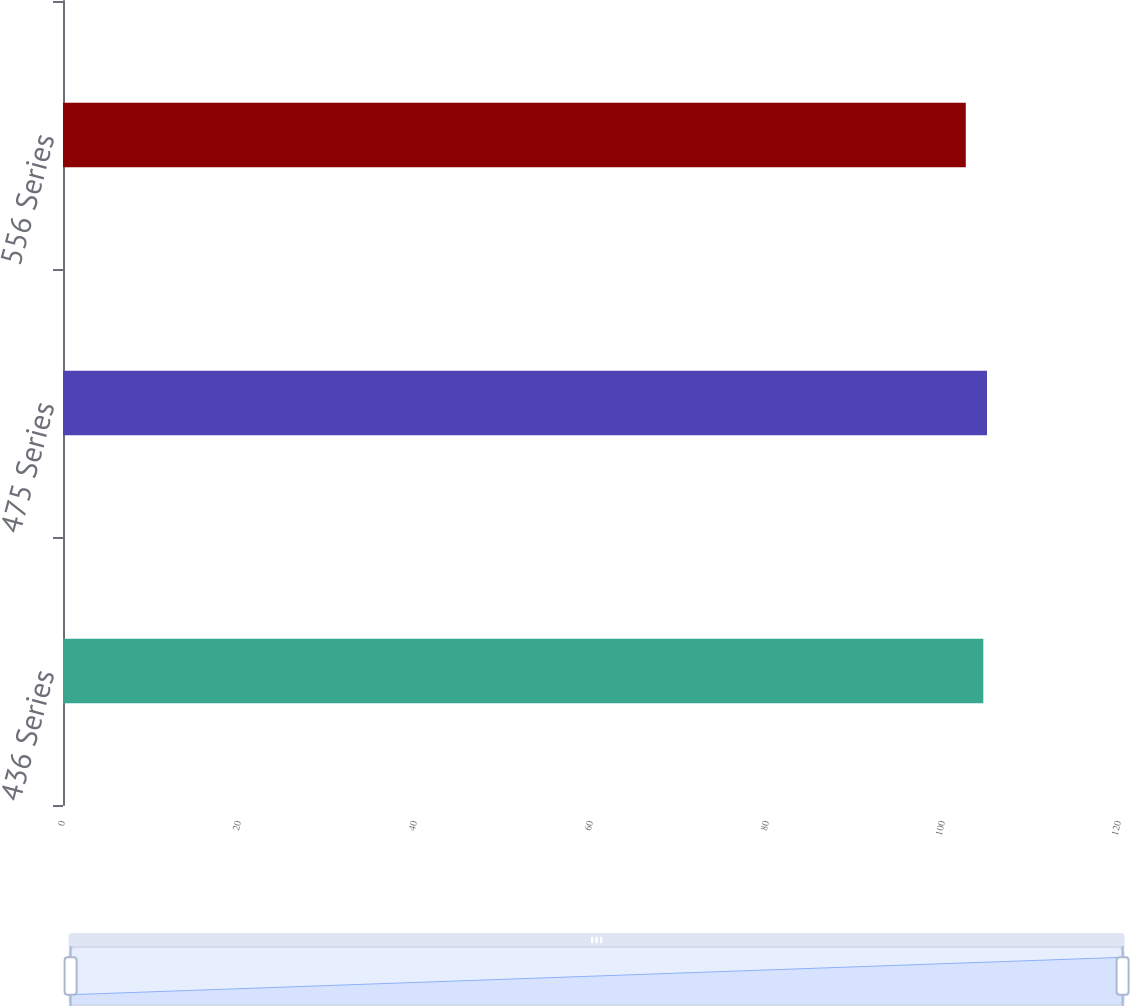<chart> <loc_0><loc_0><loc_500><loc_500><bar_chart><fcel>436 Series<fcel>475 Series<fcel>556 Series<nl><fcel>104.58<fcel>105<fcel>102.59<nl></chart> 